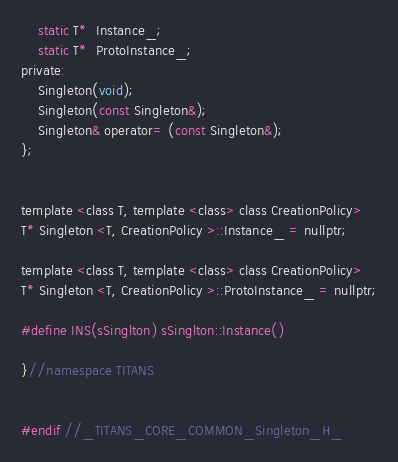Convert code to text. <code><loc_0><loc_0><loc_500><loc_500><_C_>
    static T*  Instance_;
    static T*  ProtoInstance_;
private:
    Singleton(void);
    Singleton(const Singleton&);
    Singleton& operator= (const Singleton&);
};


template <class T, template <class> class CreationPolicy>
T* Singleton <T, CreationPolicy >::Instance_ = nullptr;

template <class T, template <class> class CreationPolicy>
T* Singleton <T, CreationPolicy >::ProtoInstance_ = nullptr;

#define INS(sSinglton) sSinglton::Instance()

}//namespace TITANS


#endif //_TITANS_CORE_COMMON_Singleton_H_
</code> 